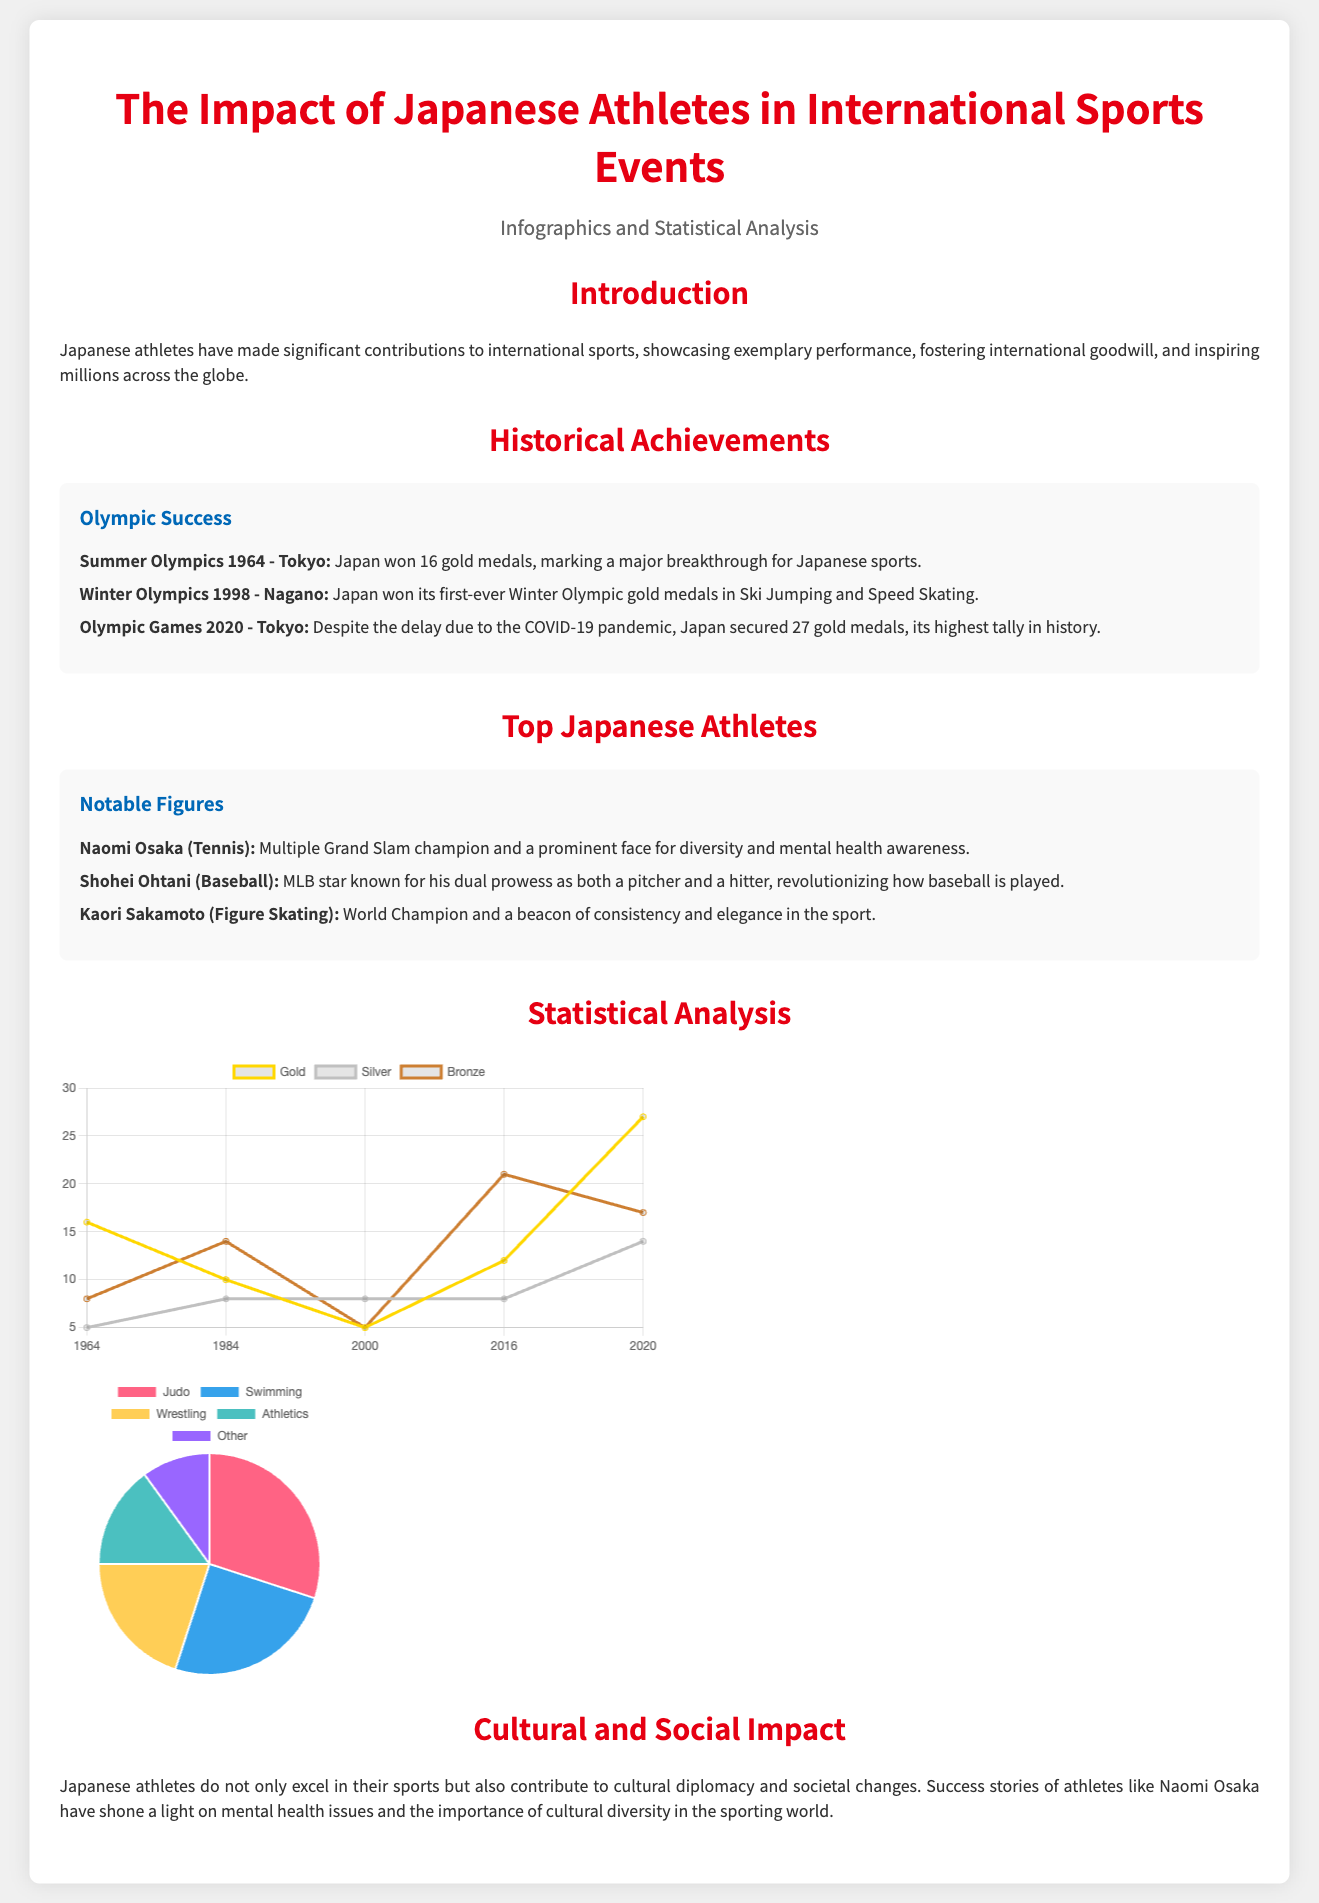What year did Japan host the Summer Olympics for the first time? The document mentions that Japan hosted the Summer Olympics in 1964.
Answer: 1964 How many gold medals did Japan win in the Tokyo Olympic Games 2020? The document states that Japan secured 27 gold medals in the Tokyo Olympic Games 2020.
Answer: 27 Who is recognized as a prominent face for diversity and mental health awareness in sports? According to the document, Naomi Osaka is noted for her contributions to diversity and mental health awareness.
Answer: Naomi Osaka What sport had the highest percentage of medal distribution according to the pie chart? The document lists Judo as having the highest percentage at 30% in the distribution of sports by medal.
Answer: Judo What significant achievement is associated with the Winter Olympics 1998? The document highlights that Japan won its first-ever Winter Olympic gold medals in Ski Jumping and Speed Skating in 1998.
Answer: First-ever Winter Olympic golds What is the purpose of including statistical analysis in the presentation? The section aims to provide a visual representation of the achievements and contributions of Japanese athletes in international sports through infographics and statistical analysis.
Answer: Visual representation Which chart shows trends in medal count over the years? The document indicates that the line chart represents the trends in medal counts over the years for Japan.
Answer: Line chart What is the primary focus of the introduction section? The introduction emphasizes the significant contributions of Japanese athletes to international sports and their inspirational impact worldwide.
Answer: Contributions to international sports 